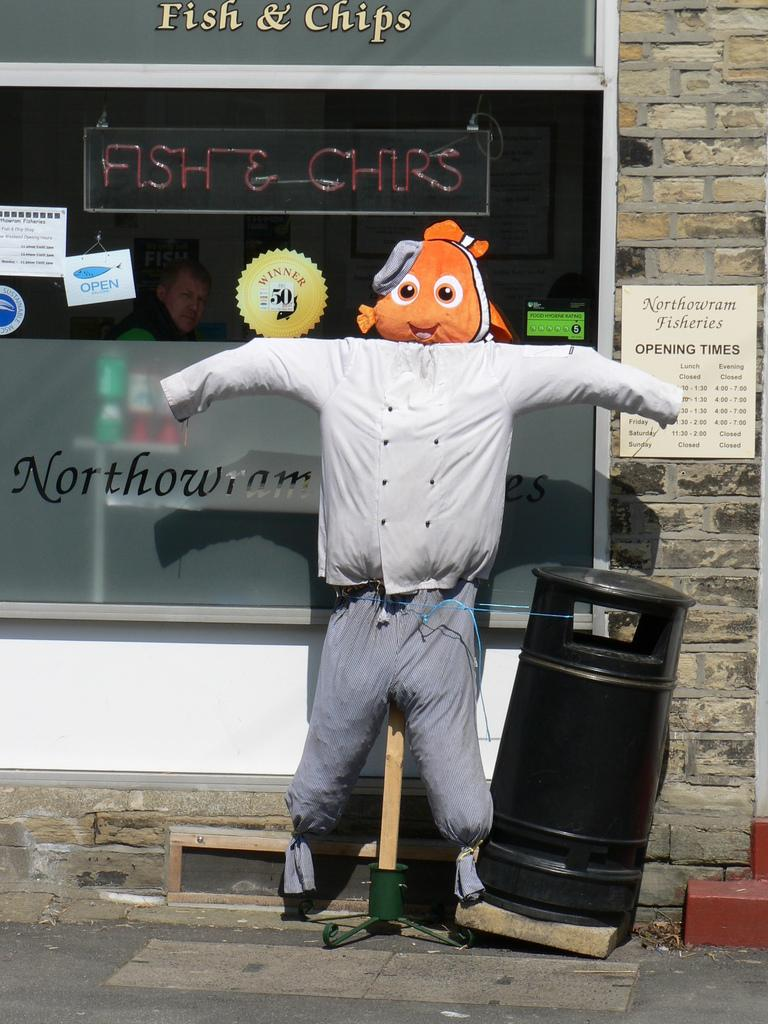<image>
Provide a brief description of the given image. A scarecrow with a stuffed fish for a head is under a sign that says Fish & Chips. 